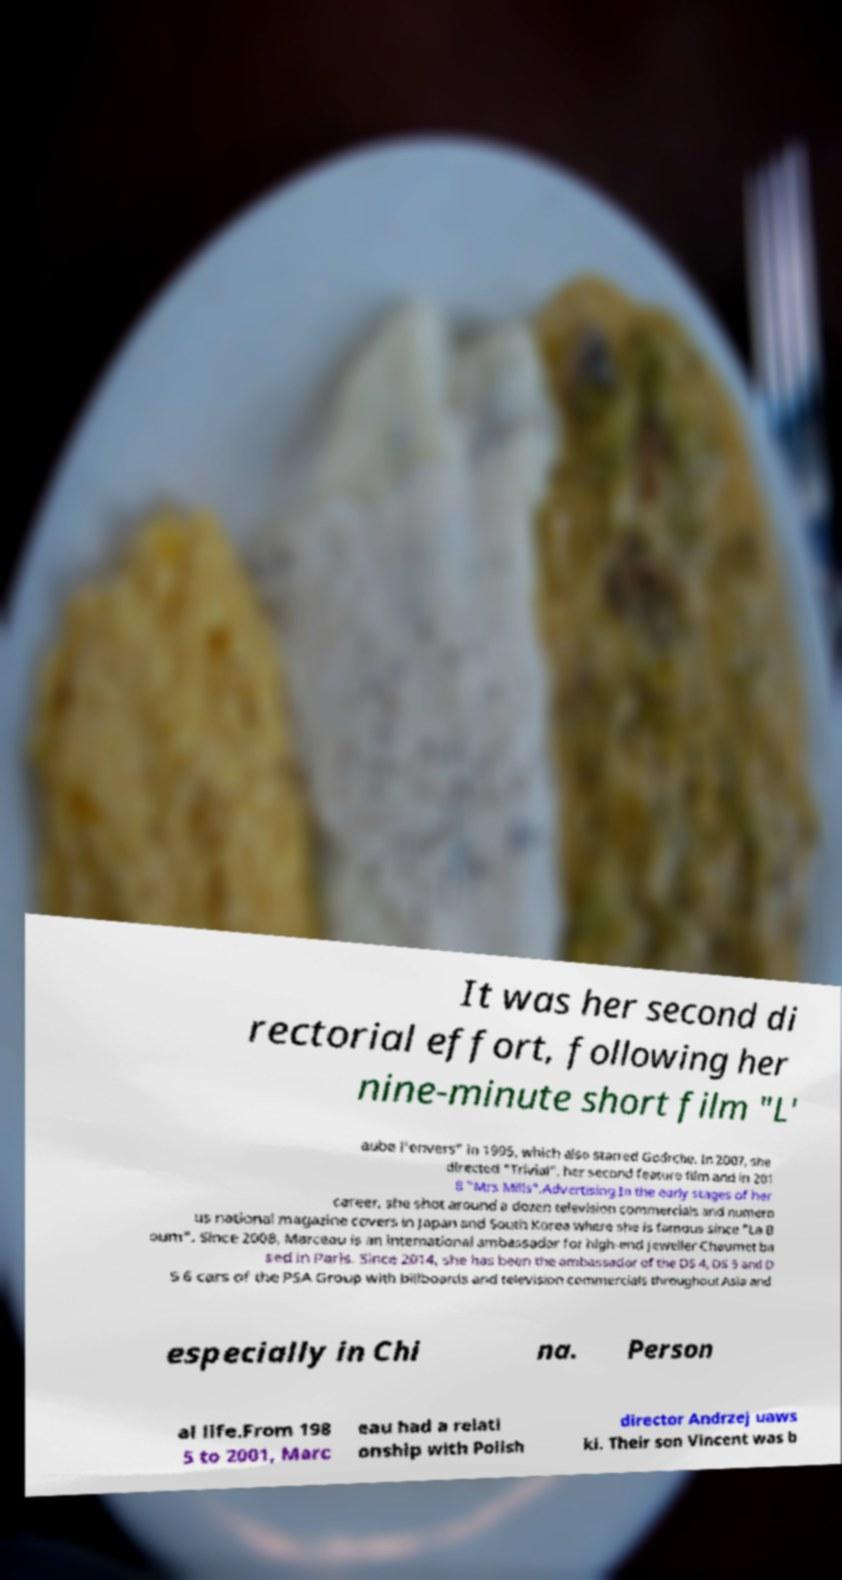Could you extract and type out the text from this image? It was her second di rectorial effort, following her nine-minute short film "L' aube l'envers" in 1995, which also starred Godrche. In 2007, she directed "Trivial", her second feature film and in 201 8 "Mrs Mills".Advertising.In the early stages of her career, she shot around a dozen television commercials and numero us national magazine covers in Japan and South Korea where she is famous since "La B oum". Since 2008, Marceau is an international ambassador for high-end jeweller Chaumet ba sed in Paris. Since 2014, she has been the ambassador of the DS 4, DS 5 and D S 6 cars of the PSA Group with billboards and television commercials throughout Asia and especially in Chi na. Person al life.From 198 5 to 2001, Marc eau had a relati onship with Polish director Andrzej uaws ki. Their son Vincent was b 